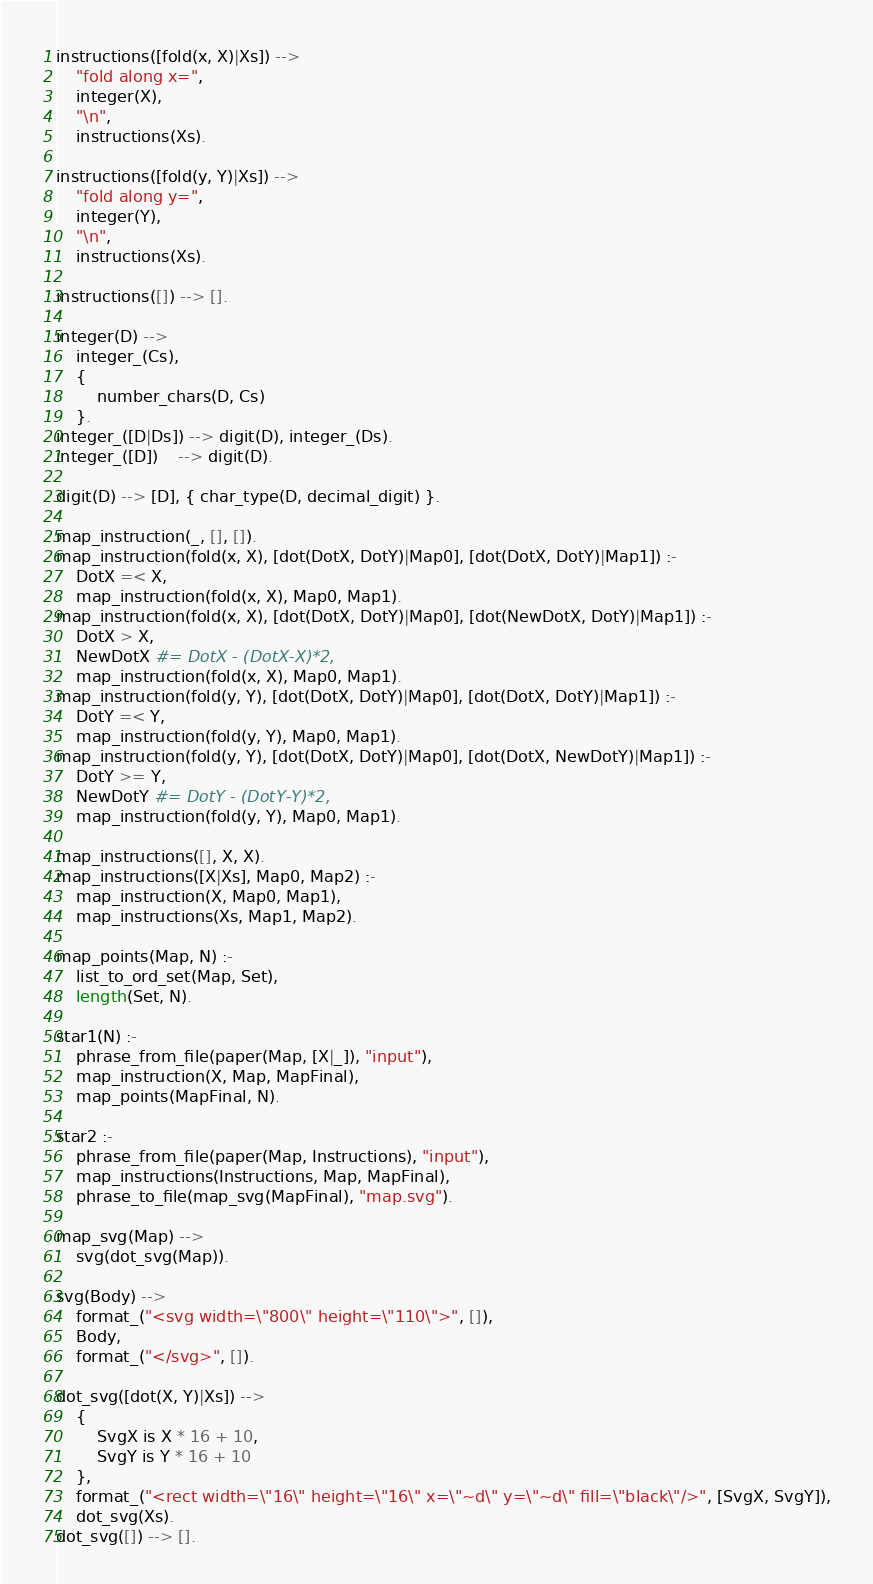Convert code to text. <code><loc_0><loc_0><loc_500><loc_500><_Perl_>
instructions([fold(x, X)|Xs]) -->
    "fold along x=",
    integer(X),
    "\n",
    instructions(Xs).

instructions([fold(y, Y)|Xs]) -->
    "fold along y=",
    integer(Y),
    "\n",
    instructions(Xs).

instructions([]) --> [].

integer(D) --> 
    integer_(Cs),
    {
        number_chars(D, Cs)
    }.
integer_([D|Ds]) --> digit(D), integer_(Ds).
integer_([D])    --> digit(D).

digit(D) --> [D], { char_type(D, decimal_digit) }.

map_instruction(_, [], []).
map_instruction(fold(x, X), [dot(DotX, DotY)|Map0], [dot(DotX, DotY)|Map1]) :-
    DotX =< X,
    map_instruction(fold(x, X), Map0, Map1).
map_instruction(fold(x, X), [dot(DotX, DotY)|Map0], [dot(NewDotX, DotY)|Map1]) :-
    DotX > X,
    NewDotX #= DotX - (DotX-X)*2,
    map_instruction(fold(x, X), Map0, Map1).
map_instruction(fold(y, Y), [dot(DotX, DotY)|Map0], [dot(DotX, DotY)|Map1]) :-
    DotY =< Y,
    map_instruction(fold(y, Y), Map0, Map1).
map_instruction(fold(y, Y), [dot(DotX, DotY)|Map0], [dot(DotX, NewDotY)|Map1]) :-
    DotY >= Y,
    NewDotY #= DotY - (DotY-Y)*2,
    map_instruction(fold(y, Y), Map0, Map1).

map_instructions([], X, X).
map_instructions([X|Xs], Map0, Map2) :-
    map_instruction(X, Map0, Map1),
    map_instructions(Xs, Map1, Map2).

map_points(Map, N) :-
    list_to_ord_set(Map, Set),
    length(Set, N).

star1(N) :-
    phrase_from_file(paper(Map, [X|_]), "input"),
    map_instruction(X, Map, MapFinal),
    map_points(MapFinal, N).

star2 :-
    phrase_from_file(paper(Map, Instructions), "input"),
    map_instructions(Instructions, Map, MapFinal),
    phrase_to_file(map_svg(MapFinal), "map.svg").

map_svg(Map) -->
    svg(dot_svg(Map)).

svg(Body) -->
    format_("<svg width=\"800\" height=\"110\">", []),
    Body,
    format_("</svg>", []).

dot_svg([dot(X, Y)|Xs]) -->
    {
        SvgX is X * 16 + 10,
        SvgY is Y * 16 + 10
    },
    format_("<rect width=\"16\" height=\"16\" x=\"~d\" y=\"~d\" fill=\"black\"/>", [SvgX, SvgY]),
    dot_svg(Xs).
dot_svg([]) --> [].</code> 